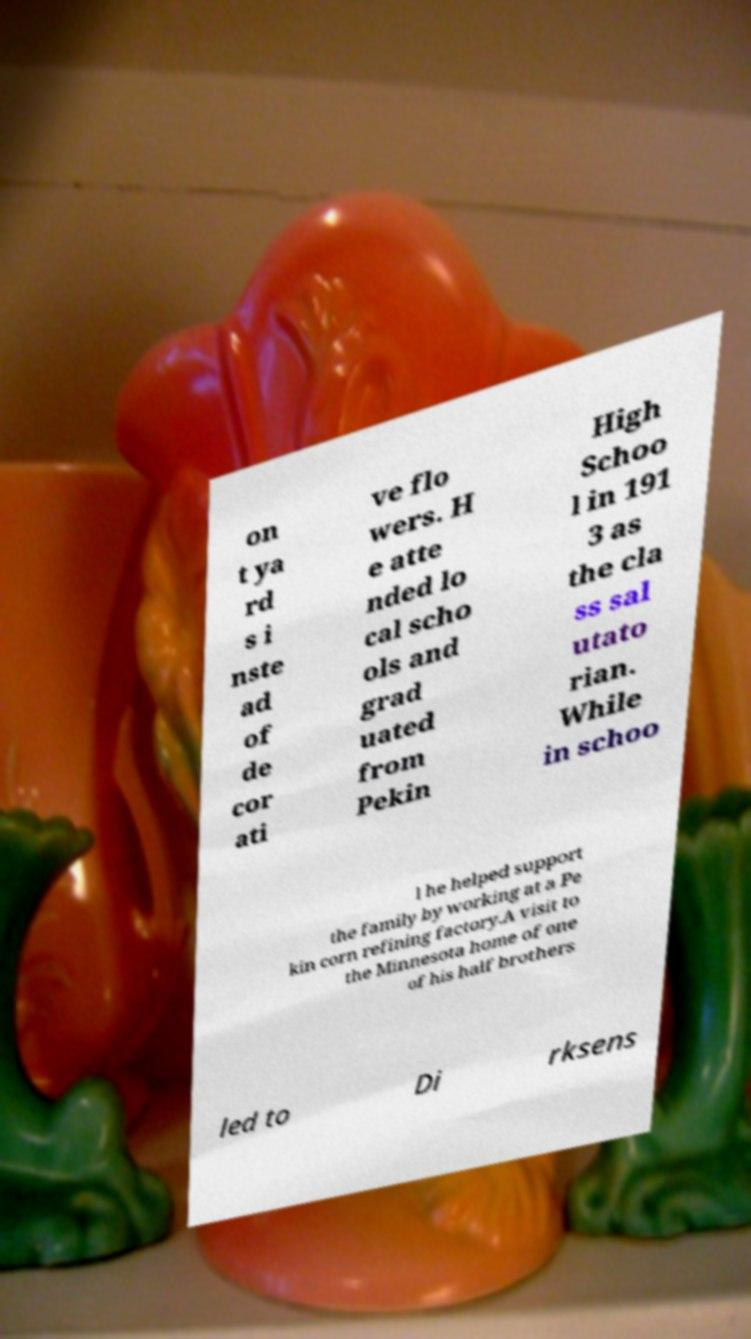For documentation purposes, I need the text within this image transcribed. Could you provide that? on t ya rd s i nste ad of de cor ati ve flo wers. H e atte nded lo cal scho ols and grad uated from Pekin High Schoo l in 191 3 as the cla ss sal utato rian. While in schoo l he helped support the family by working at a Pe kin corn refining factory.A visit to the Minnesota home of one of his half brothers led to Di rksens 